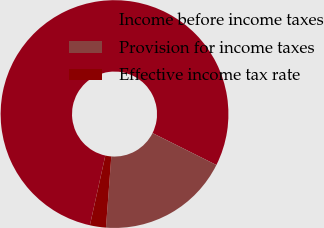Convert chart. <chart><loc_0><loc_0><loc_500><loc_500><pie_chart><fcel>Income before income taxes<fcel>Provision for income taxes<fcel>Effective income tax rate<nl><fcel>78.91%<fcel>18.82%<fcel>2.27%<nl></chart> 